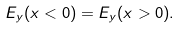<formula> <loc_0><loc_0><loc_500><loc_500>E _ { y } ( x < 0 ) = E _ { y } ( x > 0 ) .</formula> 